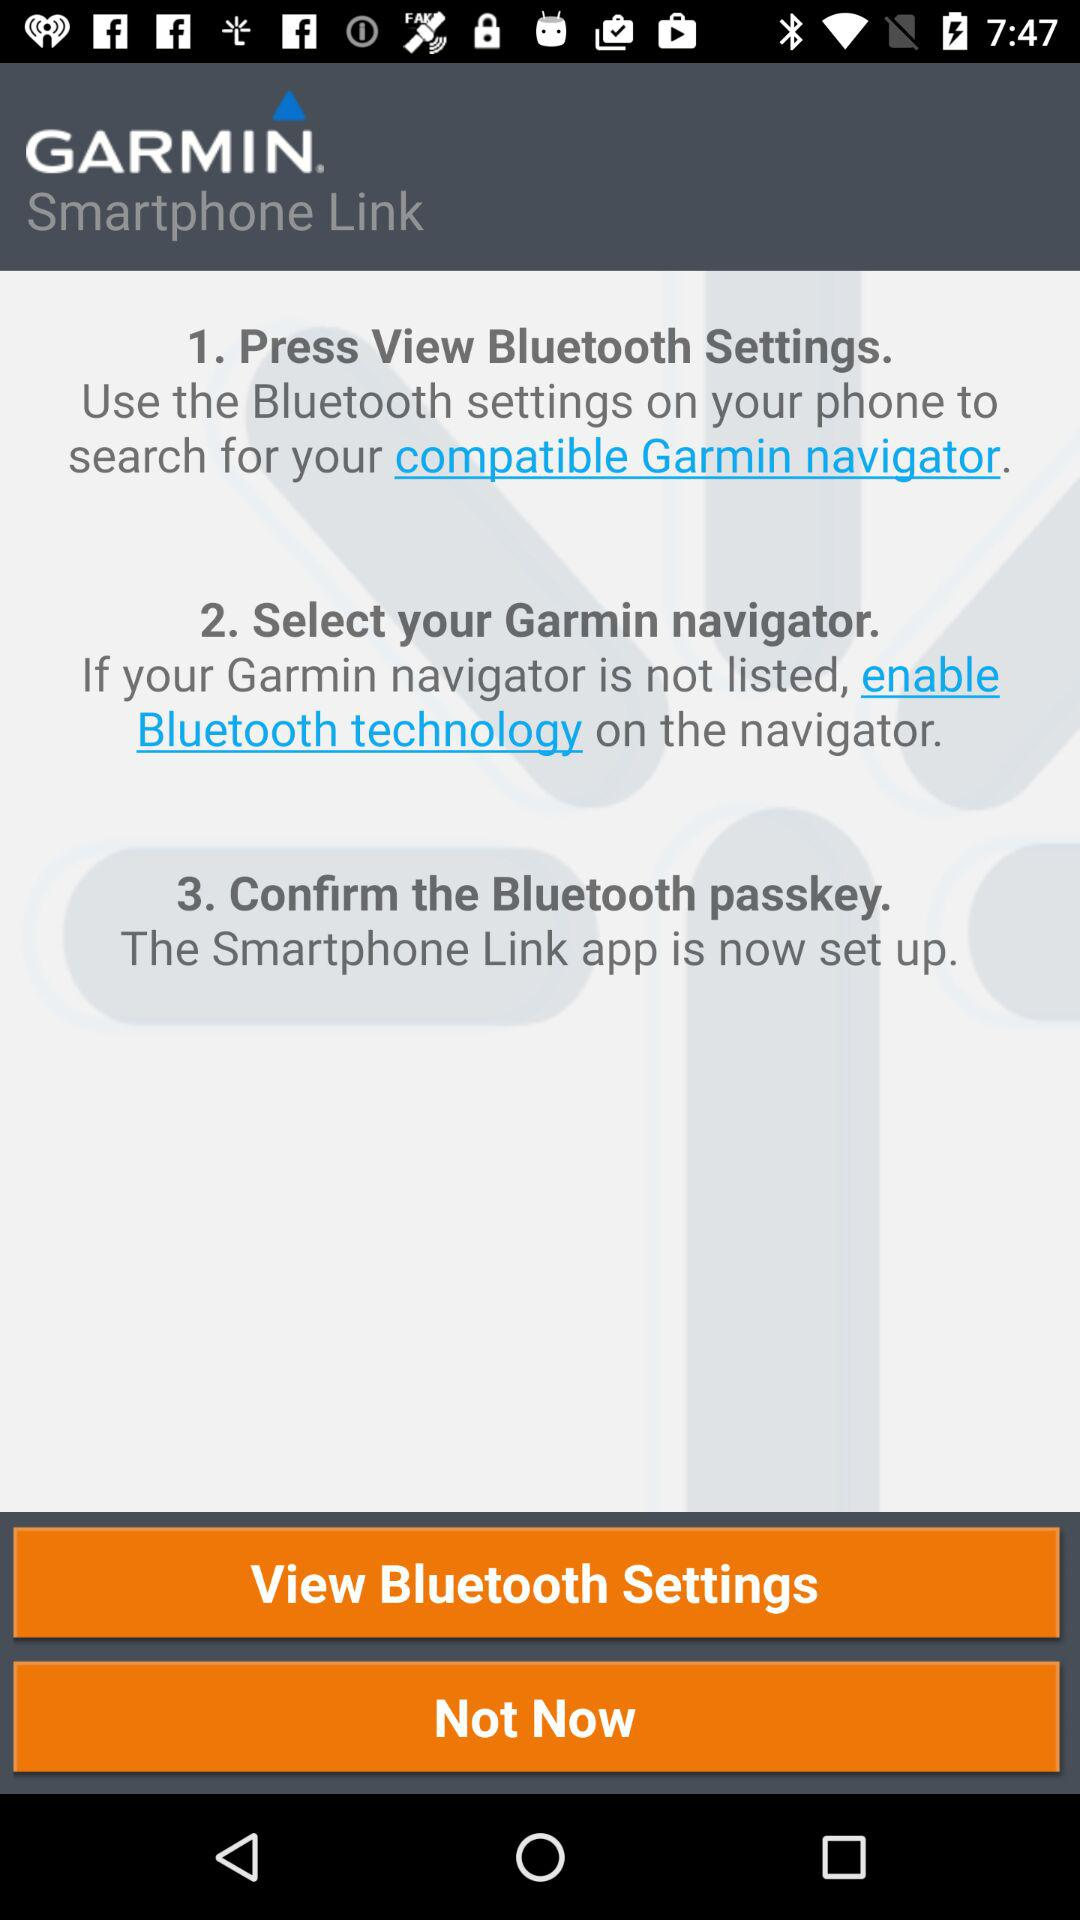How many steps are there in the process of setting up the Smartphone Link app?
Answer the question using a single word or phrase. 3 